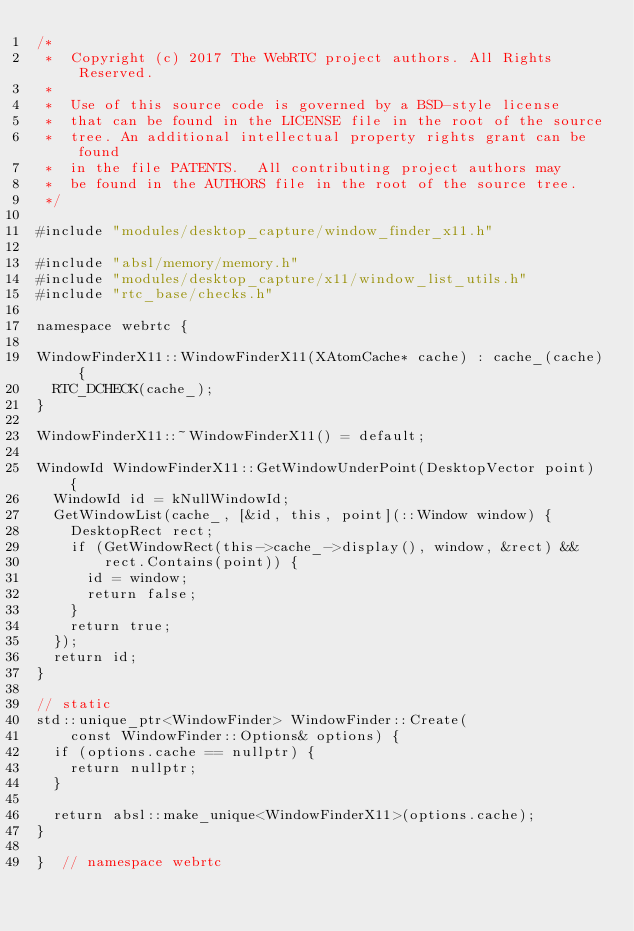Convert code to text. <code><loc_0><loc_0><loc_500><loc_500><_C++_>/*
 *  Copyright (c) 2017 The WebRTC project authors. All Rights Reserved.
 *
 *  Use of this source code is governed by a BSD-style license
 *  that can be found in the LICENSE file in the root of the source
 *  tree. An additional intellectual property rights grant can be found
 *  in the file PATENTS.  All contributing project authors may
 *  be found in the AUTHORS file in the root of the source tree.
 */

#include "modules/desktop_capture/window_finder_x11.h"

#include "absl/memory/memory.h"
#include "modules/desktop_capture/x11/window_list_utils.h"
#include "rtc_base/checks.h"

namespace webrtc {

WindowFinderX11::WindowFinderX11(XAtomCache* cache) : cache_(cache) {
  RTC_DCHECK(cache_);
}

WindowFinderX11::~WindowFinderX11() = default;

WindowId WindowFinderX11::GetWindowUnderPoint(DesktopVector point) {
  WindowId id = kNullWindowId;
  GetWindowList(cache_, [&id, this, point](::Window window) {
    DesktopRect rect;
    if (GetWindowRect(this->cache_->display(), window, &rect) &&
        rect.Contains(point)) {
      id = window;
      return false;
    }
    return true;
  });
  return id;
}

// static
std::unique_ptr<WindowFinder> WindowFinder::Create(
    const WindowFinder::Options& options) {
  if (options.cache == nullptr) {
    return nullptr;
  }

  return absl::make_unique<WindowFinderX11>(options.cache);
}

}  // namespace webrtc
</code> 